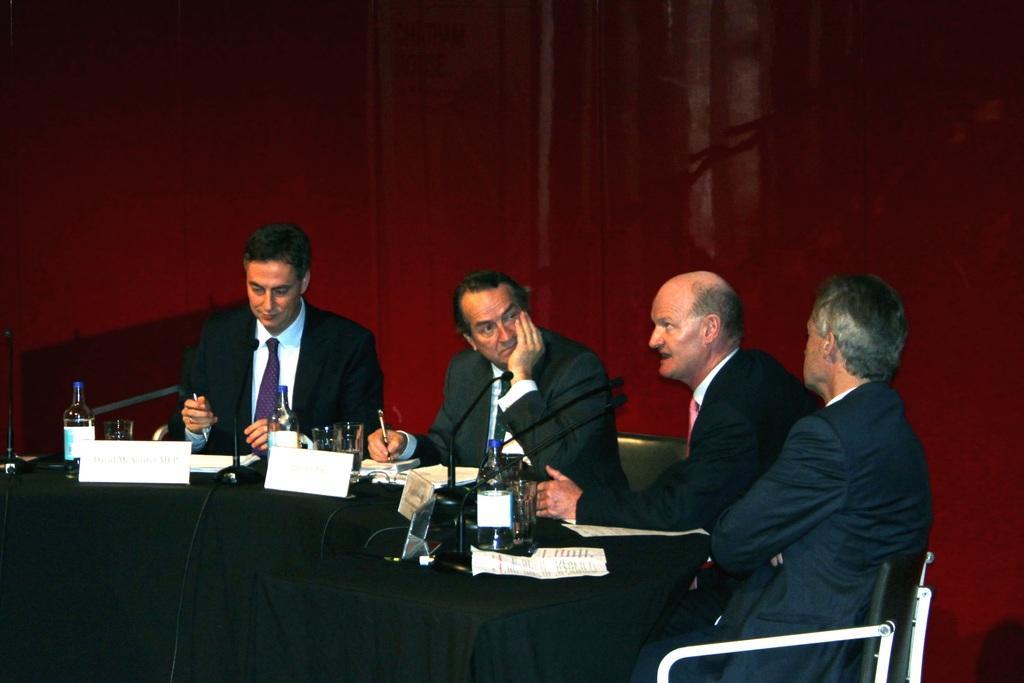Can you describe this image briefly? In this picture we can see group of people, they are all seated on the chairs, in front of them we can see few bottles, microphones, name boards and other things on the table. 